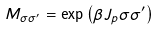Convert formula to latex. <formula><loc_0><loc_0><loc_500><loc_500>M _ { \sigma \sigma ^ { \prime } } = \exp \left ( \beta J _ { p } \sigma \sigma ^ { \prime } \right )</formula> 